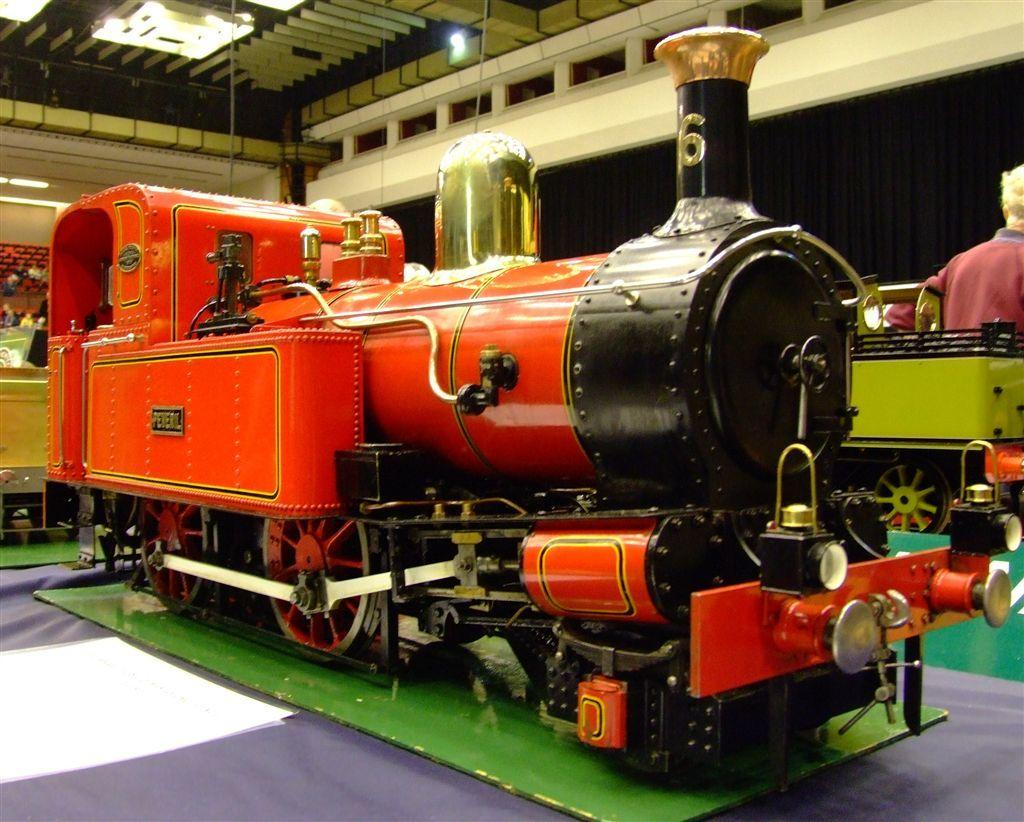What is the main subject of the image? The main subject of the image is a train. Can you describe the color of the train? The train is in black and orange color. Is there a person in the image? Yes, there is a person in the image. What is the person wearing? The person is wearing a maroon color shirt. What can be seen in the background of the image? There is a curtain in the background of the image. What color is the curtain? The curtain is in black color. How many beds are visible in the image? There are no beds visible in the image; it features a train and a person. 